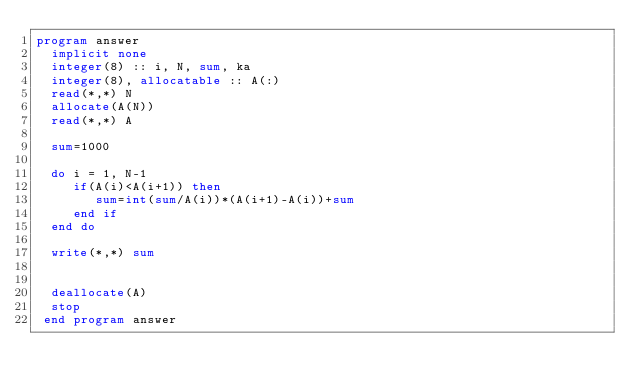Convert code to text. <code><loc_0><loc_0><loc_500><loc_500><_FORTRAN_>program answer
  implicit none
  integer(8) :: i, N, sum, ka
  integer(8), allocatable :: A(:)
  read(*,*) N
  allocate(A(N))
  read(*,*) A

  sum=1000
  
  do i = 1, N-1
     if(A(i)<A(i+1)) then
        sum=int(sum/A(i))*(A(i+1)-A(i))+sum
     end if
  end do

  write(*,*) sum
  

  deallocate(A)
  stop
 end program answer
</code> 